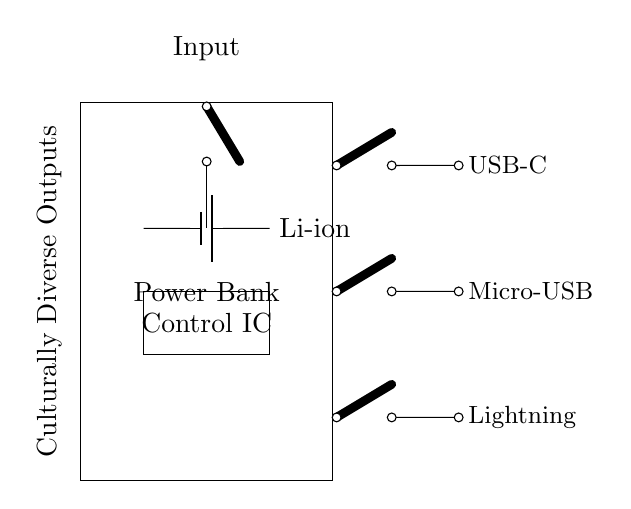What type of battery is used in this power bank? The circuit specifies a lithium-ion battery, which is a common type of rechargeable battery known for its high energy density.
Answer: Lithium-ion How many output types does the circuit provide? The circuit diagram shows three output types: USB-C, Micro-USB, and Lightning, allowing it to cater to different device charging needs.
Answer: Three What component controls the charging process? The Control IC is the component responsible for managing the charging and discharging of the battery, ensuring efficient operation and preventing issues such as overcharging.
Answer: Control IC What is the purpose of the cute open switches in the circuit? The cute open switches act as connectors for the various outputs. When switched on, they allow current to flow to the respective output, enabling devices to charge.
Answer: To connect outputs How does the power bank ensure compatibility with diverse devices? The presence of multiple output types (USB-C, Micro-USB, and Lightning) allows for compatibility with a wide range of devices, facilitating inclusivity for users with different charging needs.
Answer: By providing multiple outputs What is the significance of the "Culturally Diverse Outputs" label? This label highlights the design's intent to address the diverse cultural and technological preferences of users by supporting various charging interfaces commonly used in different regions.
Answer: It addresses cultural and technological diversity 